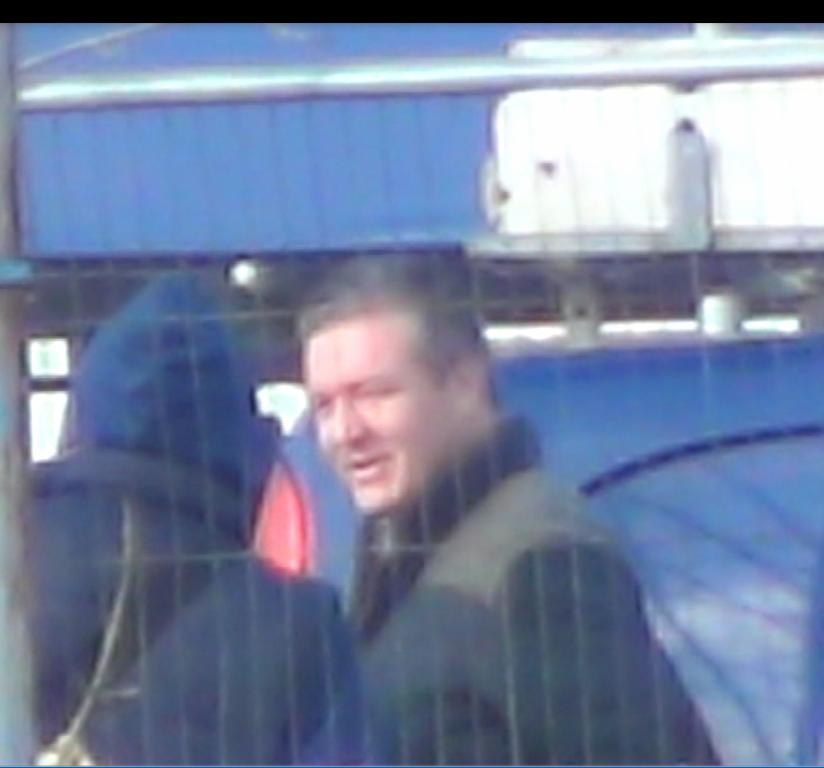How many people are in the image? There are two persons in the image. What are the two persons doing in the image? The two persons are standing. What structure can be seen in the background of the image? There is a metal shed in the image. Reasoning: Let's think step by step by step in order to produce the conversation. We start by identifying the number of people in the image, which is two. Then, we describe their actions, noting that they are standing. Finally, we mention the presence of a metal shed in the background, which provides additional context for the scene. Absurd Question/Answer: What type of steam is coming out of the metal shed in the image? There is no steam coming out of the metal shed in the image. What does the grandmother think about the two persons standing in the image? There is no mention of a grandmother in the image, so it is impossible to determine her thoughts about the two persons standing. What type of steam is coming out of the metal shed in the image? There is no steam coming out of the metal shed in the image. What does the grandmother think about the two persons standing in the image? There is no mention of a grandmother in the image, so it is impossible to determine her thoughts about the two persons standing. 